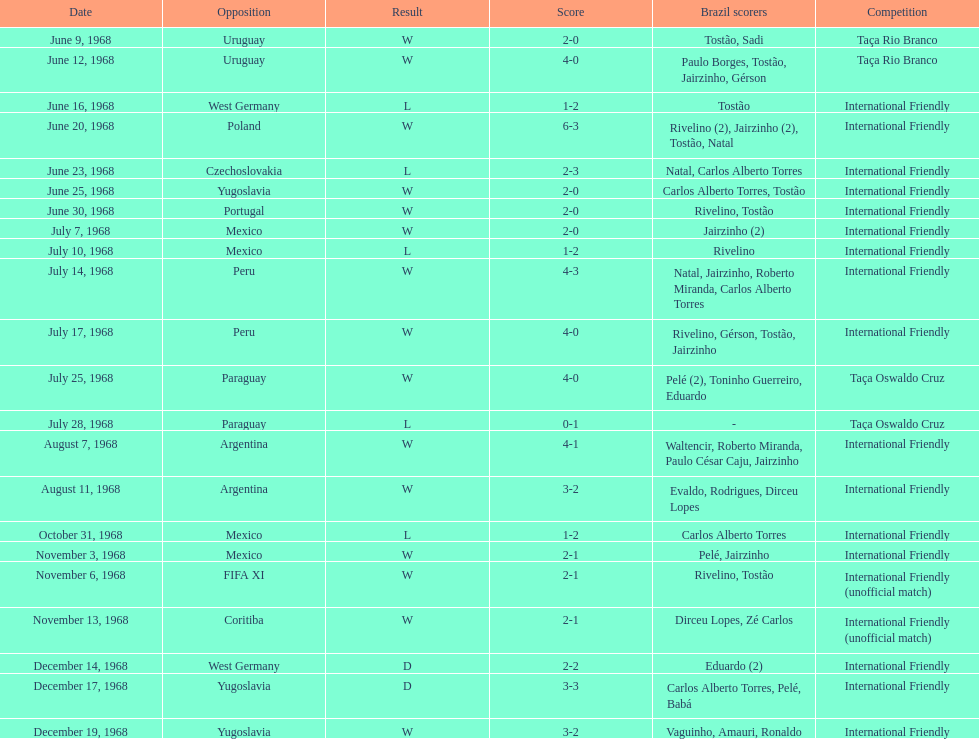Name the first competition ever played by brazil. Taça Rio Branco. 